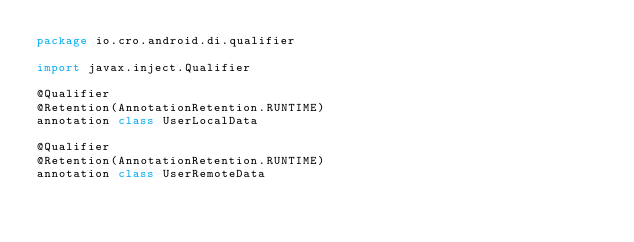Convert code to text. <code><loc_0><loc_0><loc_500><loc_500><_Kotlin_>package io.cro.android.di.qualifier

import javax.inject.Qualifier

@Qualifier
@Retention(AnnotationRetention.RUNTIME)
annotation class UserLocalData

@Qualifier
@Retention(AnnotationRetention.RUNTIME)
annotation class UserRemoteData
</code> 